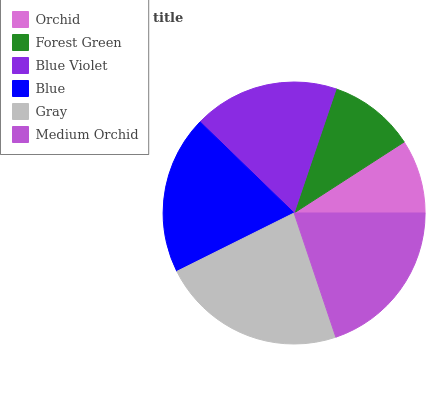Is Orchid the minimum?
Answer yes or no. Yes. Is Gray the maximum?
Answer yes or no. Yes. Is Forest Green the minimum?
Answer yes or no. No. Is Forest Green the maximum?
Answer yes or no. No. Is Forest Green greater than Orchid?
Answer yes or no. Yes. Is Orchid less than Forest Green?
Answer yes or no. Yes. Is Orchid greater than Forest Green?
Answer yes or no. No. Is Forest Green less than Orchid?
Answer yes or no. No. Is Blue the high median?
Answer yes or no. Yes. Is Blue Violet the low median?
Answer yes or no. Yes. Is Medium Orchid the high median?
Answer yes or no. No. Is Orchid the low median?
Answer yes or no. No. 